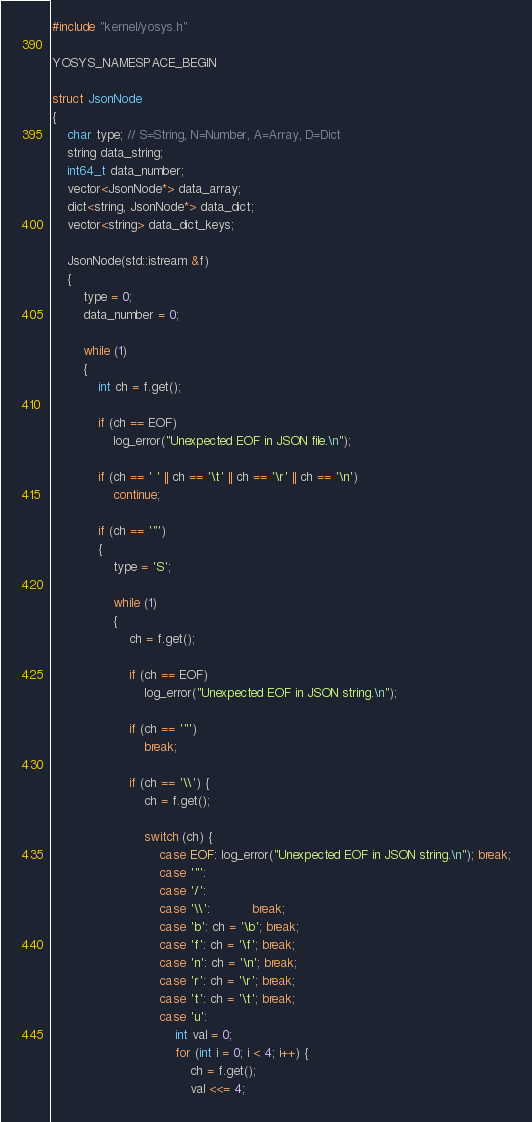<code> <loc_0><loc_0><loc_500><loc_500><_C++_>
#include "kernel/yosys.h"

YOSYS_NAMESPACE_BEGIN

struct JsonNode
{
	char type; // S=String, N=Number, A=Array, D=Dict
	string data_string;
	int64_t data_number;
	vector<JsonNode*> data_array;
	dict<string, JsonNode*> data_dict;
	vector<string> data_dict_keys;

	JsonNode(std::istream &f)
	{
		type = 0;
		data_number = 0;

		while (1)
		{
			int ch = f.get();

			if (ch == EOF)
				log_error("Unexpected EOF in JSON file.\n");

			if (ch == ' ' || ch == '\t' || ch == '\r' || ch == '\n')
				continue;

			if (ch == '"')
			{
				type = 'S';

				while (1)
				{
					ch = f.get();

					if (ch == EOF)
						log_error("Unexpected EOF in JSON string.\n");

					if (ch == '"')
						break;

					if (ch == '\\') {
						ch = f.get();

						switch (ch) {
							case EOF: log_error("Unexpected EOF in JSON string.\n"); break;
							case '"':
							case '/':
							case '\\':           break;
							case 'b': ch = '\b'; break;
							case 'f': ch = '\f'; break;
							case 'n': ch = '\n'; break;
							case 'r': ch = '\r'; break;
							case 't': ch = '\t'; break;
							case 'u':
								int val = 0;
								for (int i = 0; i < 4; i++) {
									ch = f.get();
									val <<= 4;</code> 